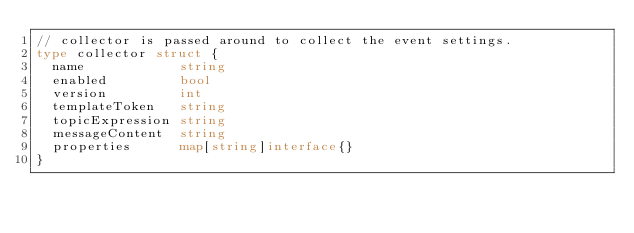<code> <loc_0><loc_0><loc_500><loc_500><_Go_>// collector is passed around to collect the event settings.
type collector struct {
	name            string
	enabled         bool
	version         int
	templateToken   string
	topicExpression string
	messageContent  string
	properties      map[string]interface{}
}
</code> 